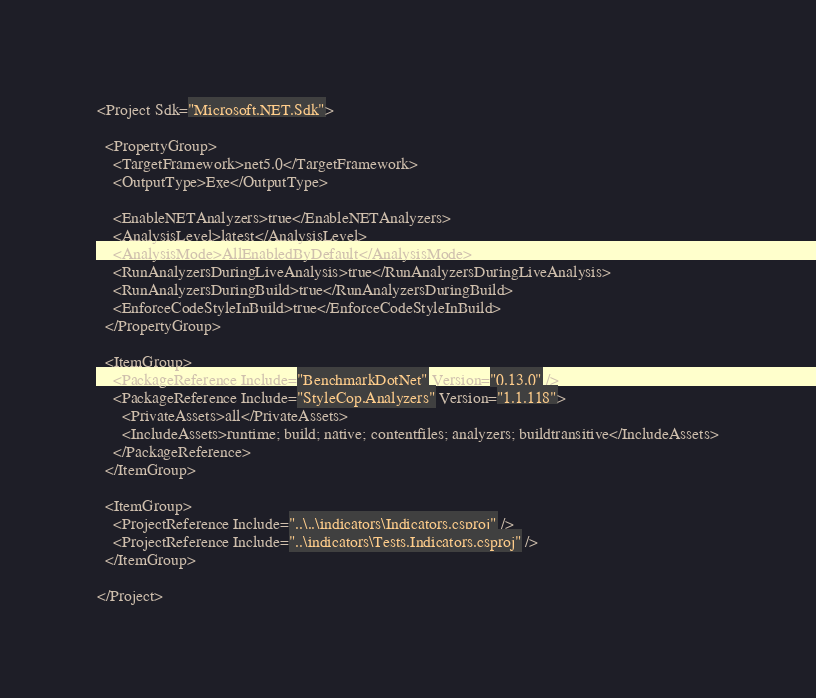<code> <loc_0><loc_0><loc_500><loc_500><_XML_><Project Sdk="Microsoft.NET.Sdk">

  <PropertyGroup>
    <TargetFramework>net5.0</TargetFramework>
    <OutputType>Exe</OutputType>

    <EnableNETAnalyzers>true</EnableNETAnalyzers>
    <AnalysisLevel>latest</AnalysisLevel>
    <AnalysisMode>AllEnabledByDefault</AnalysisMode>
    <RunAnalyzersDuringLiveAnalysis>true</RunAnalyzersDuringLiveAnalysis>
    <RunAnalyzersDuringBuild>true</RunAnalyzersDuringBuild>
    <EnforceCodeStyleInBuild>true</EnforceCodeStyleInBuild>
  </PropertyGroup>

  <ItemGroup>
    <PackageReference Include="BenchmarkDotNet" Version="0.13.0" />
    <PackageReference Include="StyleCop.Analyzers" Version="1.1.118">
      <PrivateAssets>all</PrivateAssets>
      <IncludeAssets>runtime; build; native; contentfiles; analyzers; buildtransitive</IncludeAssets>
    </PackageReference>
  </ItemGroup>

  <ItemGroup>
    <ProjectReference Include="..\..\indicators\Indicators.csproj" />
    <ProjectReference Include="..\indicators\Tests.Indicators.csproj" />
  </ItemGroup>

</Project>
</code> 